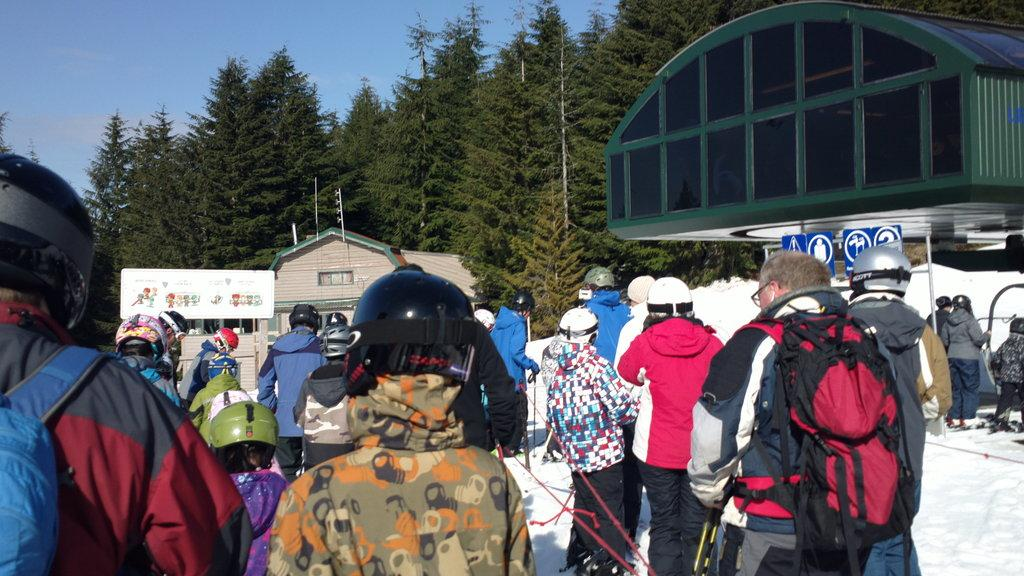Who or what is present in the image? There are people in the image. What is the surface the people are standing on? The people are on the snow. What can be seen in the distance behind the people? There are buildings, trees, and the sky visible in the background of the image. What type of drum can be heard in the image? There is no drum present in the image, so it is not possible to hear any drum sounds. 